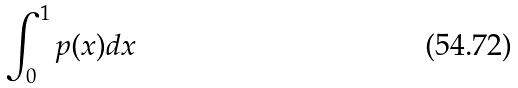Convert formula to latex. <formula><loc_0><loc_0><loc_500><loc_500>\int _ { 0 } ^ { 1 } p ( x ) d x</formula> 